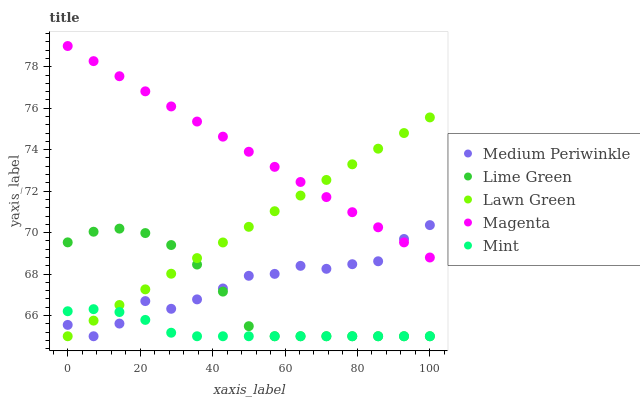Does Mint have the minimum area under the curve?
Answer yes or no. Yes. Does Magenta have the maximum area under the curve?
Answer yes or no. Yes. Does Medium Periwinkle have the minimum area under the curve?
Answer yes or no. No. Does Medium Periwinkle have the maximum area under the curve?
Answer yes or no. No. Is Magenta the smoothest?
Answer yes or no. Yes. Is Medium Periwinkle the roughest?
Answer yes or no. Yes. Is Medium Periwinkle the smoothest?
Answer yes or no. No. Is Magenta the roughest?
Answer yes or no. No. Does Lime Green have the lowest value?
Answer yes or no. Yes. Does Magenta have the lowest value?
Answer yes or no. No. Does Magenta have the highest value?
Answer yes or no. Yes. Does Medium Periwinkle have the highest value?
Answer yes or no. No. Is Mint less than Magenta?
Answer yes or no. Yes. Is Magenta greater than Lime Green?
Answer yes or no. Yes. Does Lawn Green intersect Lime Green?
Answer yes or no. Yes. Is Lawn Green less than Lime Green?
Answer yes or no. No. Is Lawn Green greater than Lime Green?
Answer yes or no. No. Does Mint intersect Magenta?
Answer yes or no. No. 